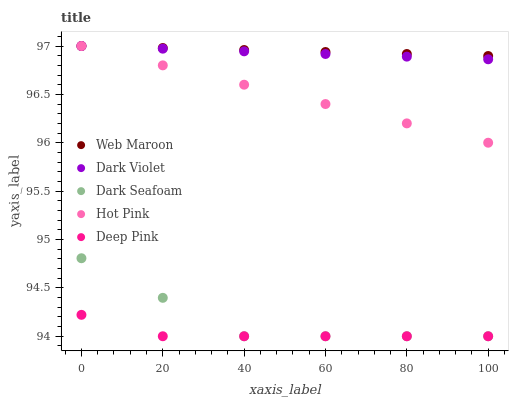Does Deep Pink have the minimum area under the curve?
Answer yes or no. Yes. Does Web Maroon have the maximum area under the curve?
Answer yes or no. Yes. Does Hot Pink have the minimum area under the curve?
Answer yes or no. No. Does Hot Pink have the maximum area under the curve?
Answer yes or no. No. Is Hot Pink the smoothest?
Answer yes or no. Yes. Is Dark Seafoam the roughest?
Answer yes or no. Yes. Is Dark Violet the smoothest?
Answer yes or no. No. Is Dark Violet the roughest?
Answer yes or no. No. Does Dark Seafoam have the lowest value?
Answer yes or no. Yes. Does Hot Pink have the lowest value?
Answer yes or no. No. Does Dark Violet have the highest value?
Answer yes or no. Yes. Does Deep Pink have the highest value?
Answer yes or no. No. Is Dark Seafoam less than Web Maroon?
Answer yes or no. Yes. Is Web Maroon greater than Deep Pink?
Answer yes or no. Yes. Does Dark Violet intersect Web Maroon?
Answer yes or no. Yes. Is Dark Violet less than Web Maroon?
Answer yes or no. No. Is Dark Violet greater than Web Maroon?
Answer yes or no. No. Does Dark Seafoam intersect Web Maroon?
Answer yes or no. No. 